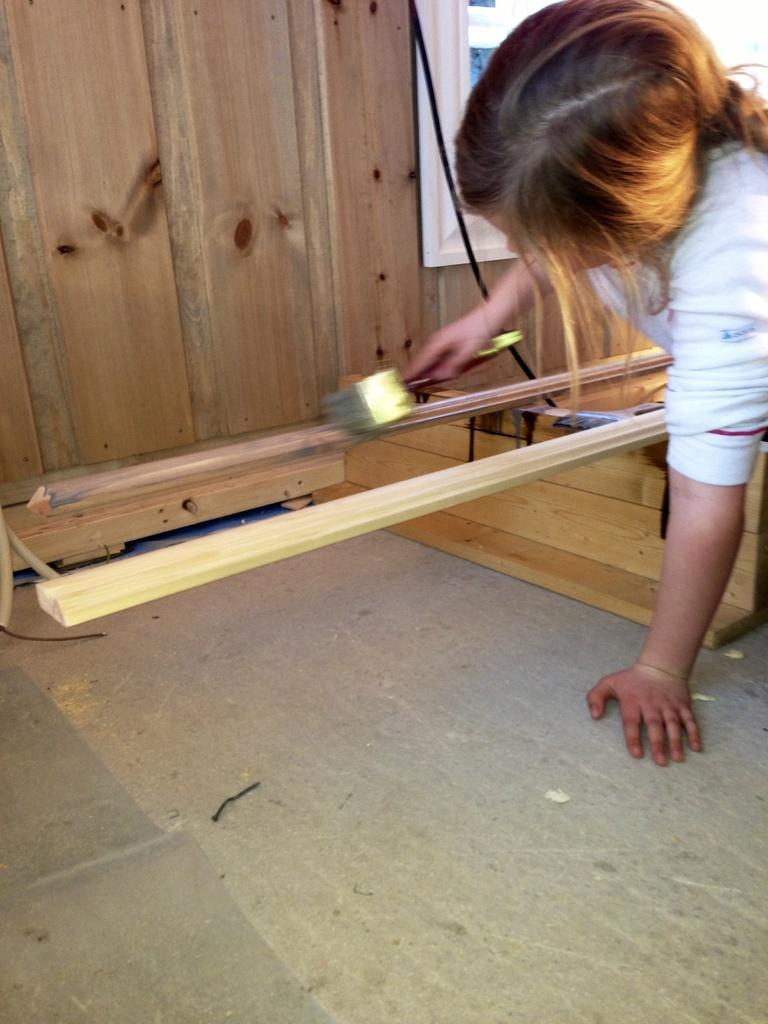Who is the main subject in the image? There is a girl in the image. What is the girl wearing? The girl is wearing a white dress. What object is the girl holding? The girl is holding a brush. What type of pets can be seen in the image? There are no pets visible in the image; it features a girl holding a brush. What is the girl using the brush for on the plate in the image? There is no plate present in the image, and the girl is not using the brush for any specific purpose. 